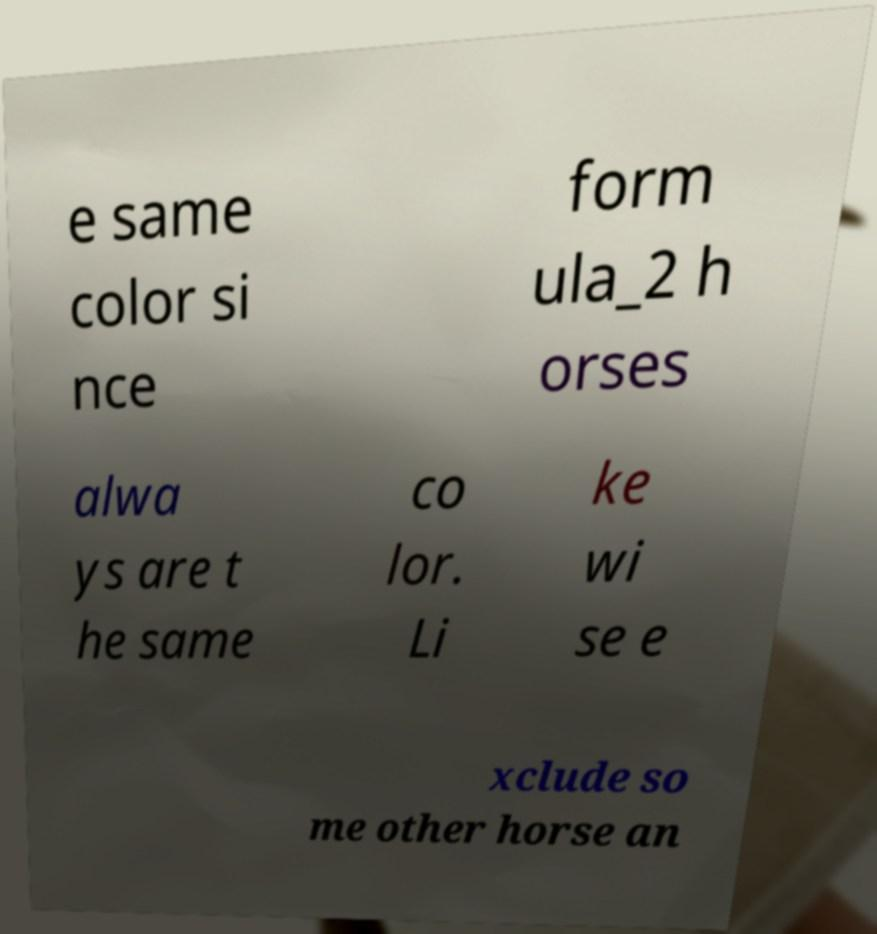Could you extract and type out the text from this image? e same color si nce form ula_2 h orses alwa ys are t he same co lor. Li ke wi se e xclude so me other horse an 